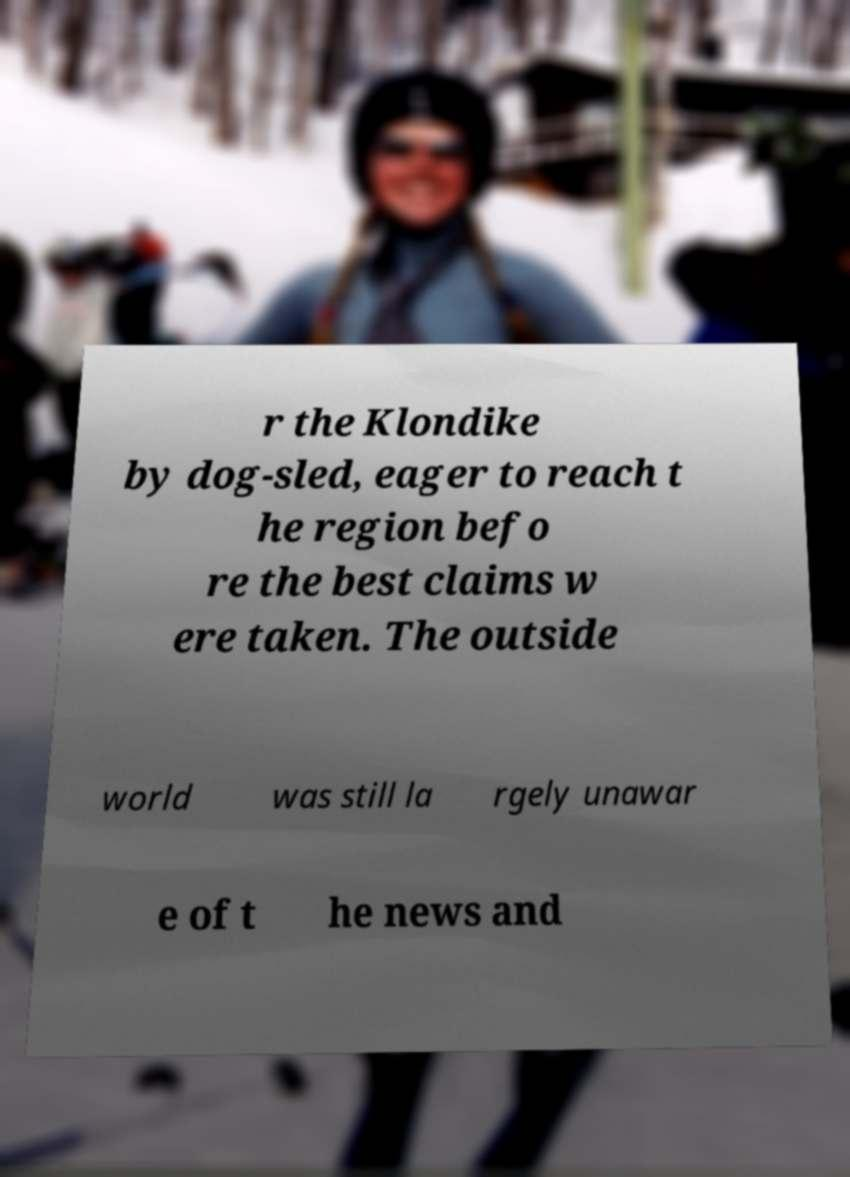What messages or text are displayed in this image? I need them in a readable, typed format. r the Klondike by dog-sled, eager to reach t he region befo re the best claims w ere taken. The outside world was still la rgely unawar e of t he news and 